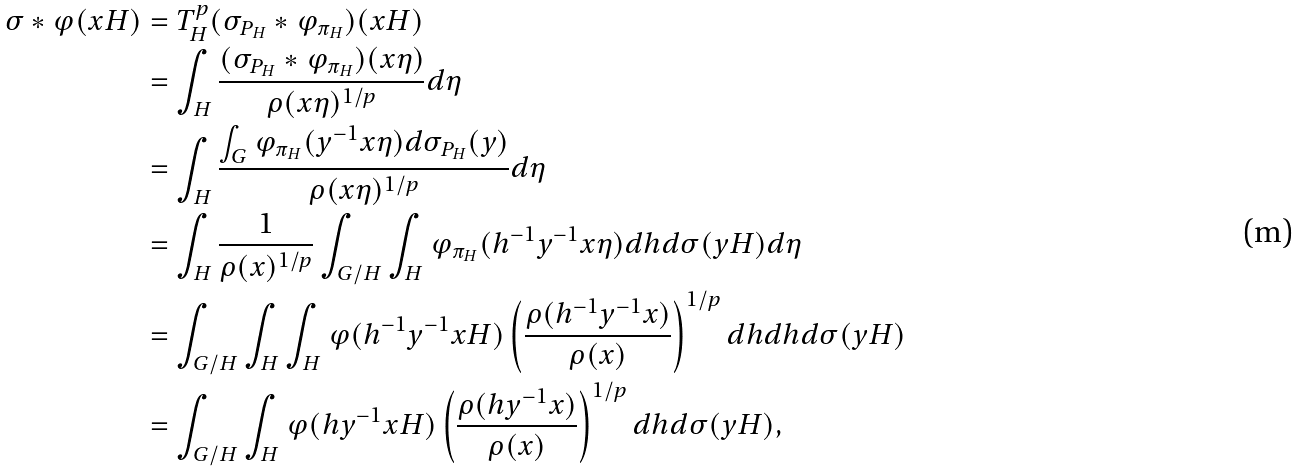Convert formula to latex. <formula><loc_0><loc_0><loc_500><loc_500>\sigma \ast \varphi ( x H ) & = T _ { H } ^ { p } ( \sigma _ { P _ { H } } \ast \varphi _ { \pi _ { H } } ) ( x H ) \\ & = \int _ { H } { \frac { ( \sigma _ { P _ { H } } \ast \varphi _ { \pi _ { H } } ) ( x \eta ) } { \rho ( x \eta ) ^ { 1 / p } } d \eta } \\ & = \int _ { H } { \frac { \int _ { G } { \varphi _ { \pi _ { H } } ( y ^ { - 1 } x \eta ) d \sigma _ { P _ { H } } ( y ) } } { \rho ( x \eta ) ^ { 1 / p } } d \eta } \\ & = \int _ { H } { \frac { 1 } { \rho ( x ) ^ { 1 / p } } \int _ { G / H } { \int _ { H } { \varphi _ { \pi _ { H } } ( h ^ { - 1 } y ^ { - 1 } x \eta ) d h d \sigma ( y H ) d \eta } } } \\ & = \int _ { G / H } { \int _ { H } { \int _ { H } { \varphi ( h ^ { - 1 } y ^ { - 1 } x H ) \left ( \frac { \rho ( h ^ { - 1 } y ^ { - 1 } x ) } { \rho ( x ) } \right ) ^ { 1 / p } d h d h d \sigma ( y H ) } } } \\ & = \int _ { G / H } { \int _ { H } { \varphi ( h y ^ { - 1 } x H ) \left ( \frac { \rho ( h y ^ { - 1 } x ) } { \rho ( x ) } \right ) ^ { 1 / p } d h d \sigma ( y H ) } } ,</formula> 